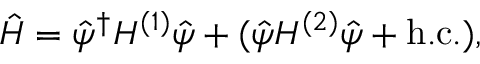Convert formula to latex. <formula><loc_0><loc_0><loc_500><loc_500>\hat { H } = \hat { \psi } ^ { \dagger } H ^ { ( 1 ) } \hat { \psi } + ( \hat { \psi } H ^ { ( 2 ) } \hat { \psi } + h . c . ) ,</formula> 